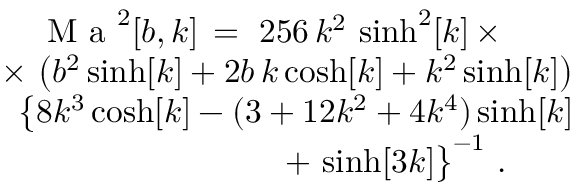<formula> <loc_0><loc_0><loc_500><loc_500>\begin{array} { r } { M a ^ { 2 } [ b , k ] \, = \, 2 5 6 \, k ^ { 2 } \, \sinh ^ { 2 } [ k ] \, \times \, \quad } \\ { \times \, \left ( b ^ { 2 } \sinh [ k ] + 2 b \, k \cosh [ k ] + k ^ { 2 } \sinh [ k ] \right ) } \\ { \, \left \{ 8 k ^ { 3 } \cosh [ k ] - ( 3 + 1 2 k ^ { 2 } + 4 k ^ { 4 } ) \sinh [ k ] } \\ { + \, \sinh [ 3 k ] \right \} ^ { - 1 } \ . \quad } \end{array}</formula> 